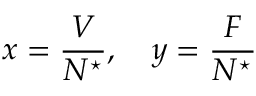<formula> <loc_0><loc_0><loc_500><loc_500>x = \frac { V } { N ^ { ^ { * } } } , \quad y = \frac { F } { N ^ { ^ { * } } }</formula> 